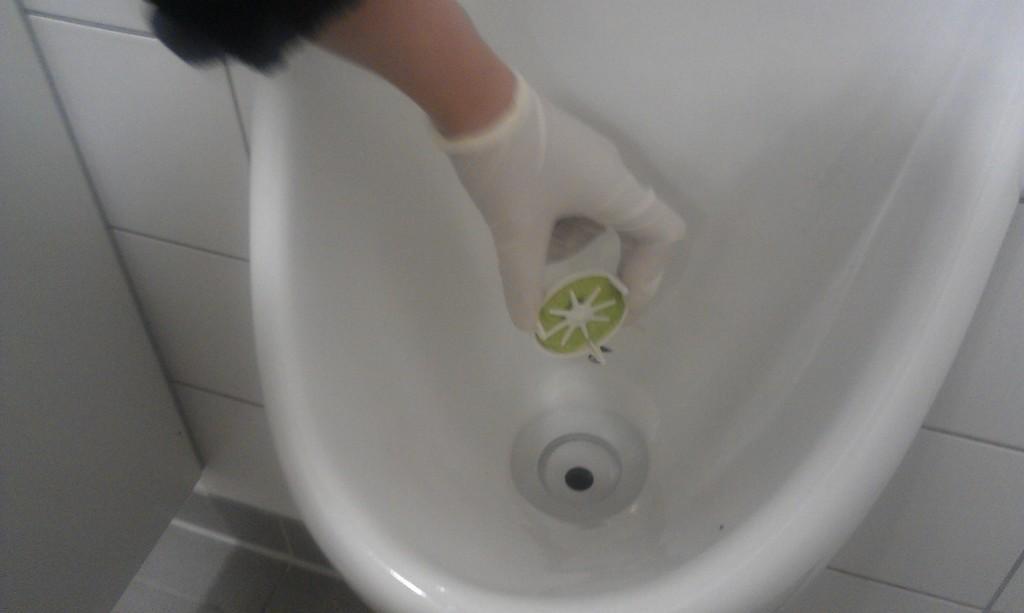In one or two sentences, can you explain what this image depicts? In this image in the center there is wash basin and one person's hand is visible and the person is holding something, in the background there is wall. 